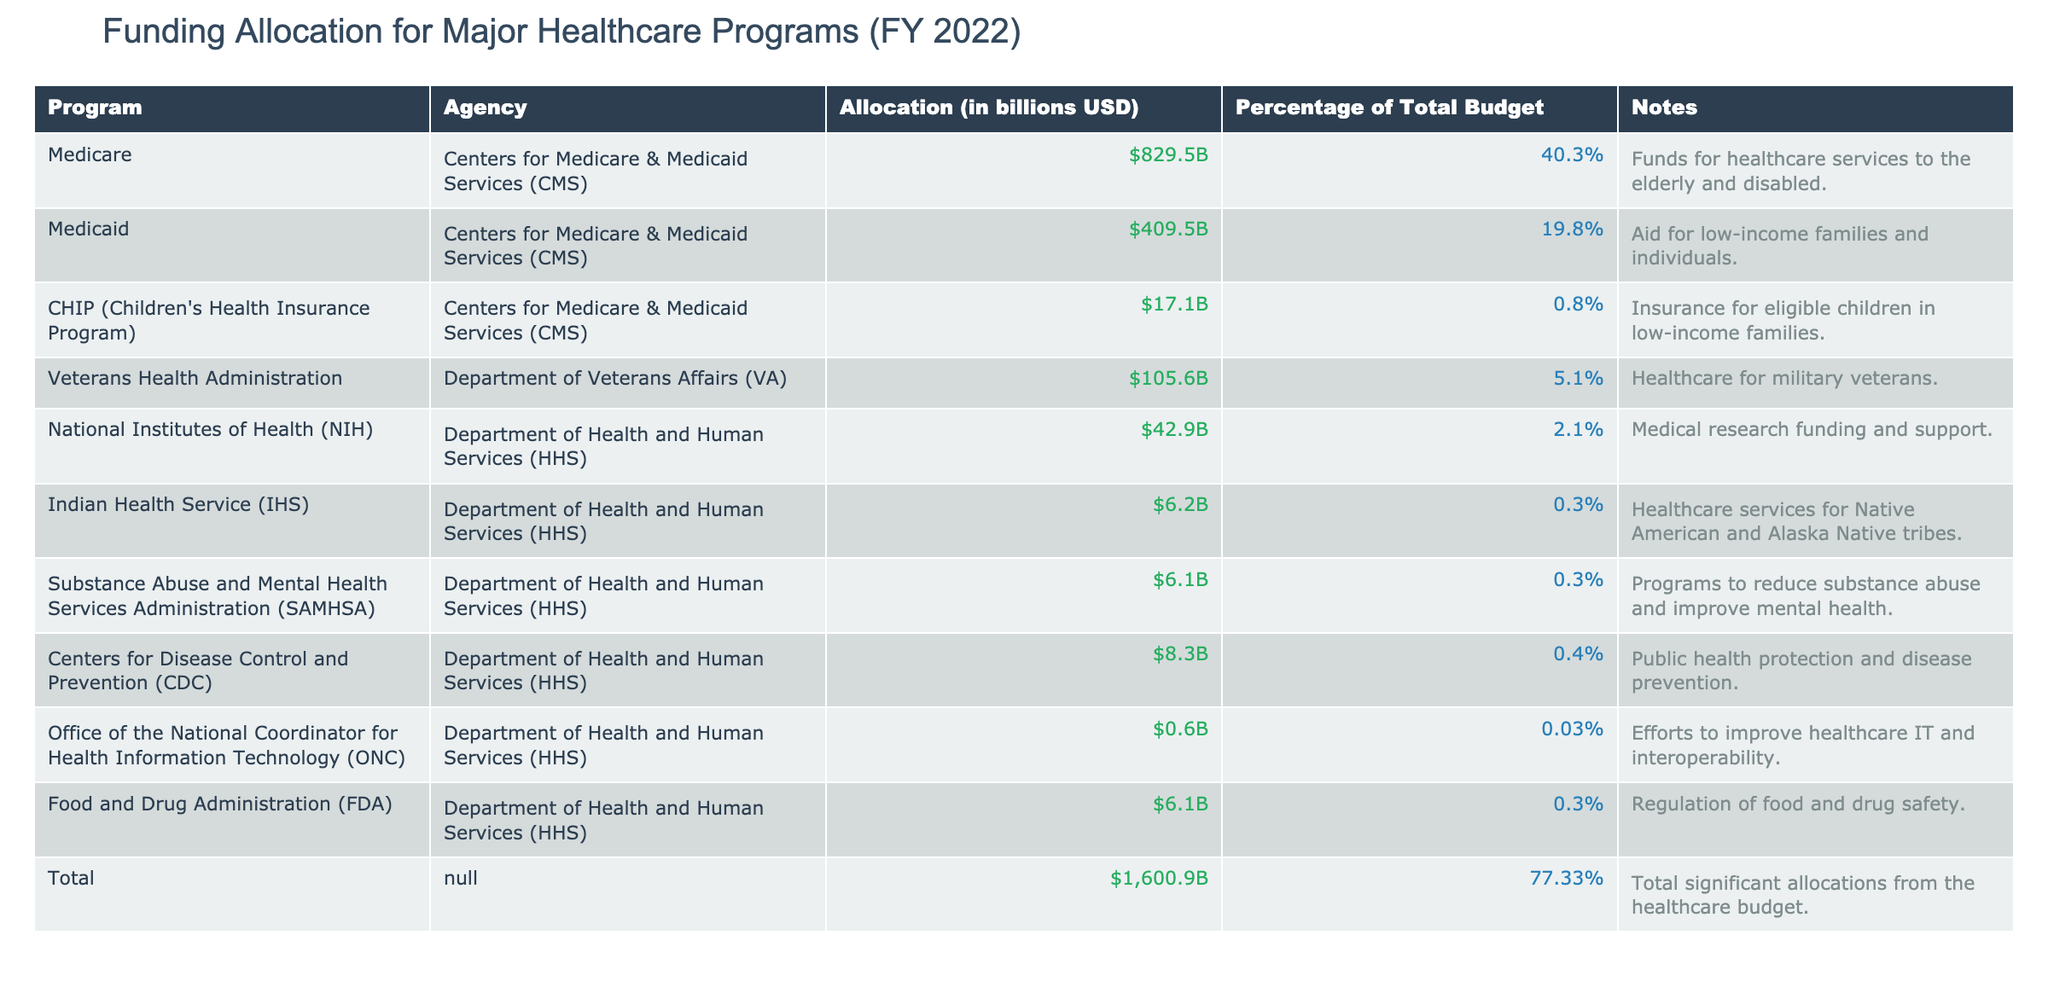What is the allocation for Medicare? The table lists Medicare's allocation under the "Allocation (in billions USD)" column, where it shows that Medicare received $829.5 billion.
Answer: $829.5 billion Which program receives the smallest allocation? In the table, the program with the smallest allocation is the Office of the National Coordinator for Health Information Technology (ONC), which received $0.6 billion.
Answer: Office of the National Coordinator for Health Information Technology (ONC) What is the total allocation for all listed programs? The table provides a "Total" row summing all allocations, which indicates the total allocation for all listed programs is $1,600.9 billion.
Answer: $1,600.9 billion Is the allocation for Medicaid more than that of Veterans Health Administration? By comparing the two allocations in the table, Medicaid received $409.5 billion and the Veterans Health Administration received $105.6 billion, which shows that Medicaid’s allocation is indeed more.
Answer: Yes What percentage of the total budget is allocated to the National Institutes of Health (NIH)? To find this, the table gives the allocation for NIH as $42.9 billion and the total budget as $1,600.9 billion. The percentage of the total budget allocated to NIH is calculated by dividing NIH's allocation by the total budget: (42.9 / 1600.9) * 100%, which gives approximately 2.7%. This percentage is slightly higher than the listed percentage of 2.1% due to rounding considerations.
Answer: 2.1% What is the total percentage allocation for programs under the Department of Health and Human Services (HHS)? To find this percentage, we add the allocations of all HHS programs listed: NIH (2.1%), IHS (0.3%), SAMHSA (0.3%), CDC (0.4%), ONC (0.03%), and FDA (0.3%). Summing these percentages gives approximately 3.43%, which can be rounded based on details in the table. The total percentage from the table is 3.4%.
Answer: 3.4% How much more is allocated to Medicare compared to Medicaid? The allocation for Medicare is $829.5 billion and for Medicaid it is $409.5 billion. The difference is calculated as 829.5 - 409.5 = $420 billion.
Answer: $420 billion Are the total allocations for Medicare and Medicaid greater than 50% of the total budget? We first add both allocations: Medicare ($829.5 billion) and Medicaid ($409.5 billion) which equals $1,239 billion. Then we check if this is greater than 50% of the total budget, which is $1,600.9 billion. Calculating 50% of the total budget gives $800.45 billion, indicating that $1,239 billion exceeds that amount.
Answer: Yes 